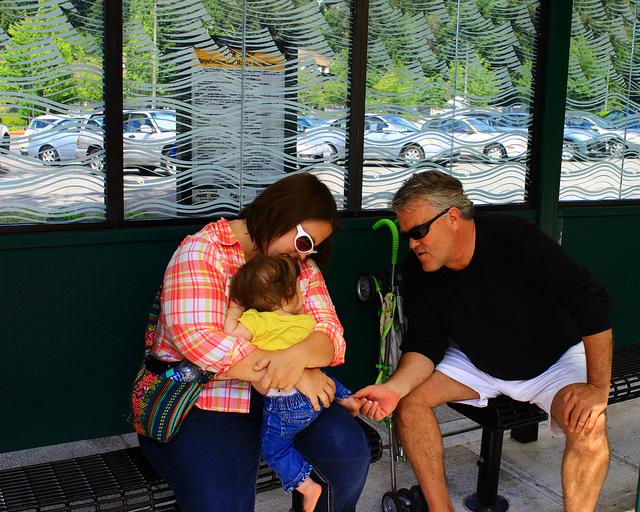Is that a baby girl?
Answer briefly. Yes. What is the woman holding?
Short answer required. Baby. Is the man wearing sunglasses?
Answer briefly. Yes. 